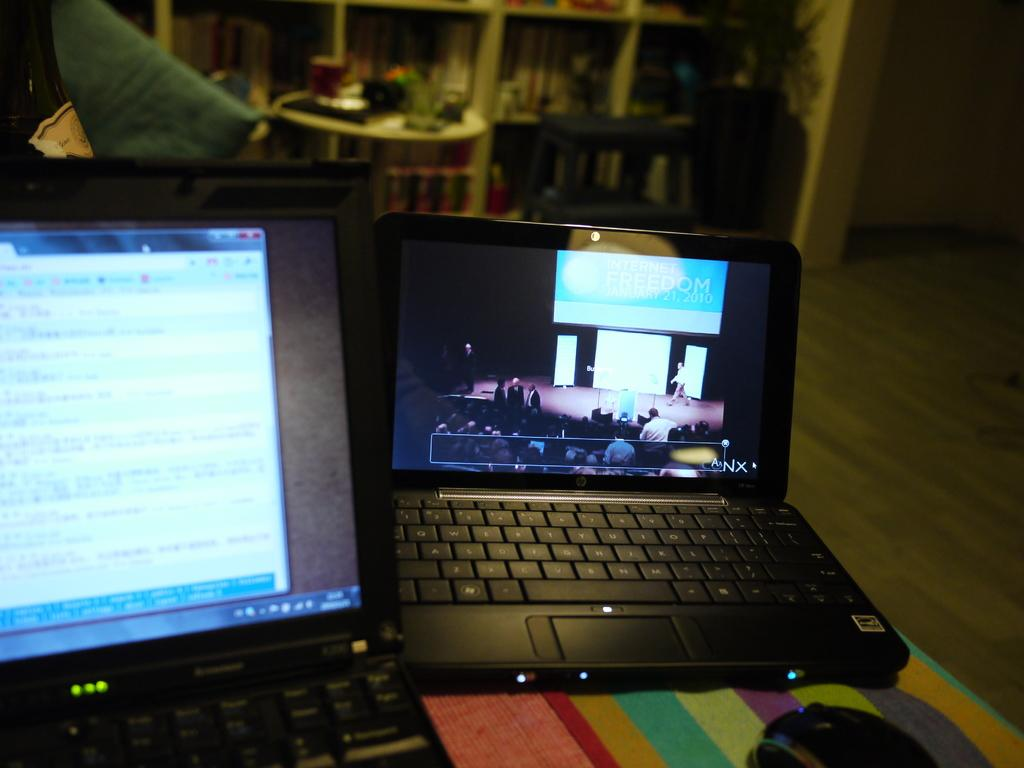Provide a one-sentence caption for the provided image. Two laptops sitting on a table with one showing Canx. 